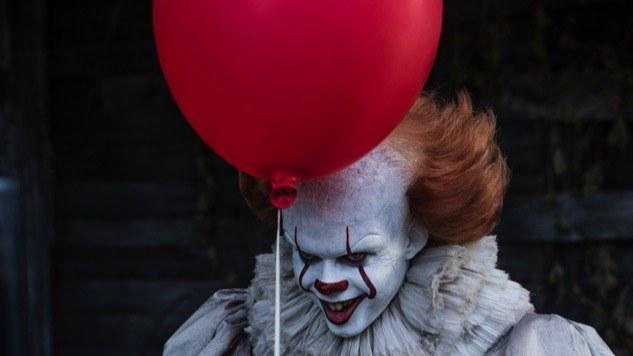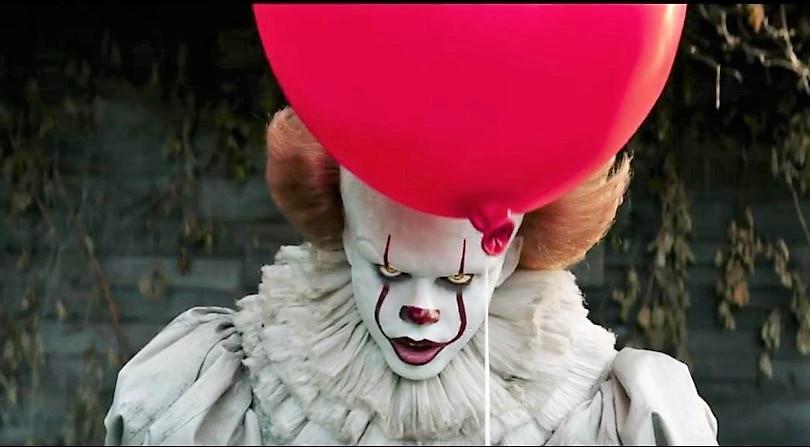The first image is the image on the left, the second image is the image on the right. For the images displayed, is the sentence "There are four eyes." factually correct? Answer yes or no. Yes. 